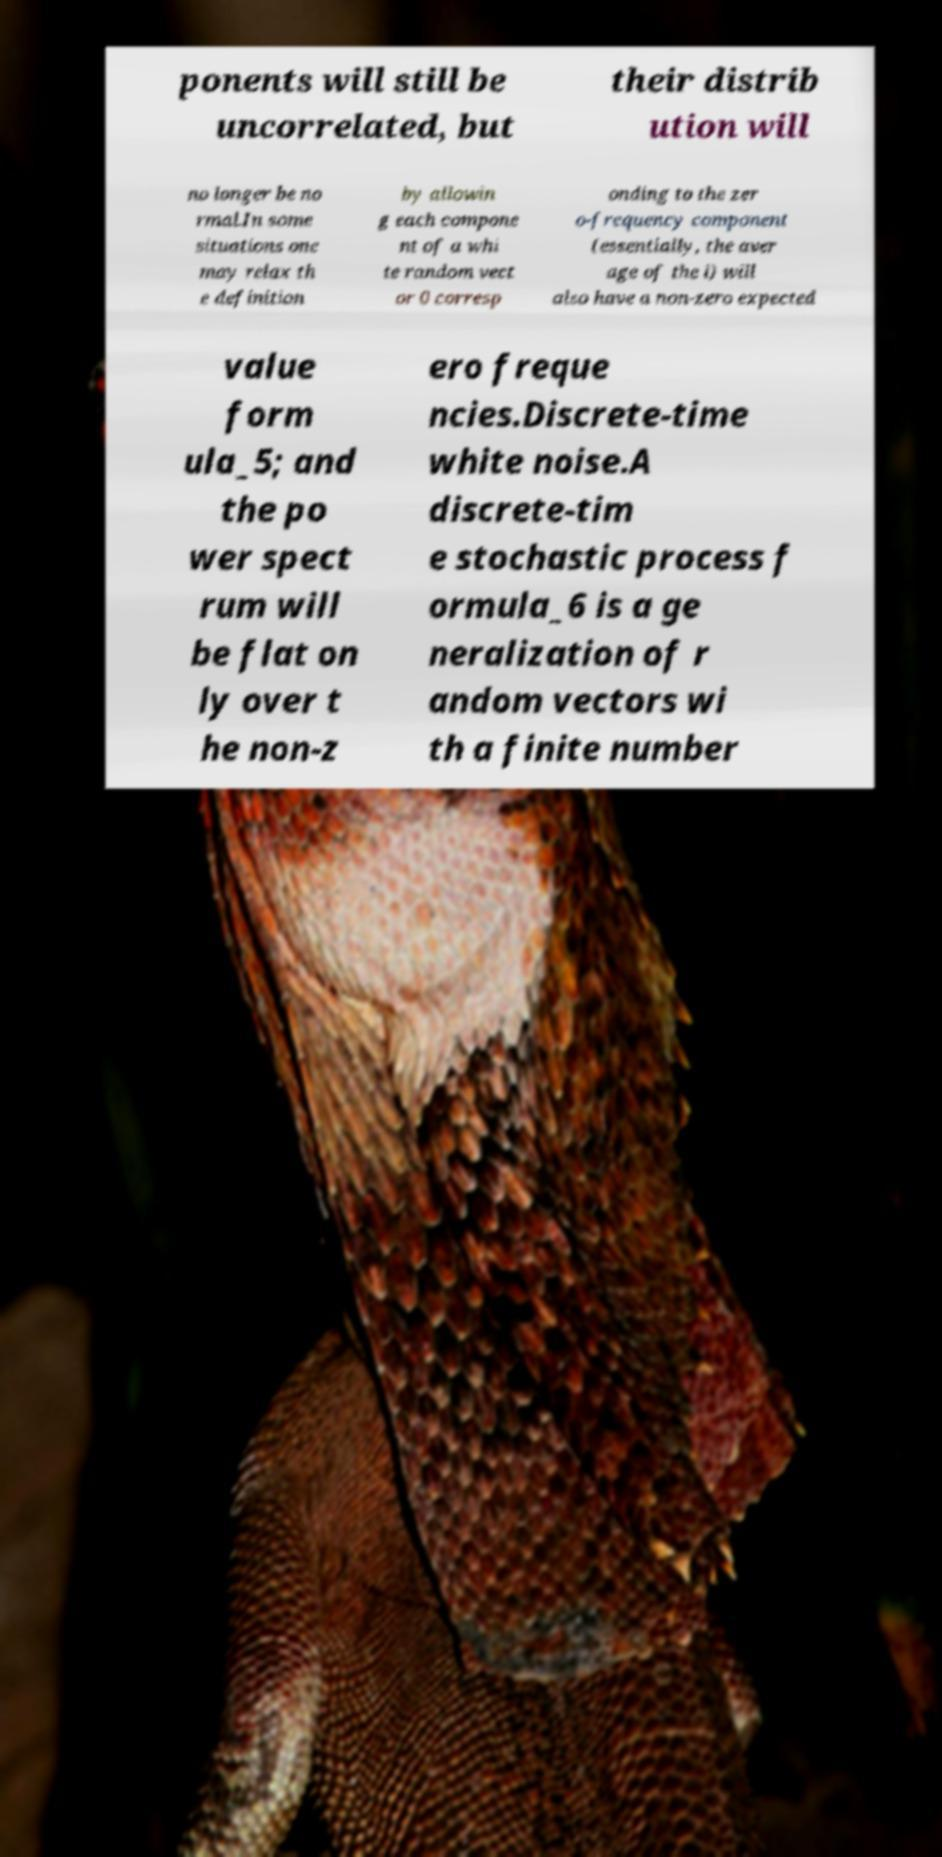Please read and relay the text visible in this image. What does it say? ponents will still be uncorrelated, but their distrib ution will no longer be no rmal.In some situations one may relax th e definition by allowin g each compone nt of a whi te random vect or 0 corresp onding to the zer o-frequency component (essentially, the aver age of the i) will also have a non-zero expected value form ula_5; and the po wer spect rum will be flat on ly over t he non-z ero freque ncies.Discrete-time white noise.A discrete-tim e stochastic process f ormula_6 is a ge neralization of r andom vectors wi th a finite number 